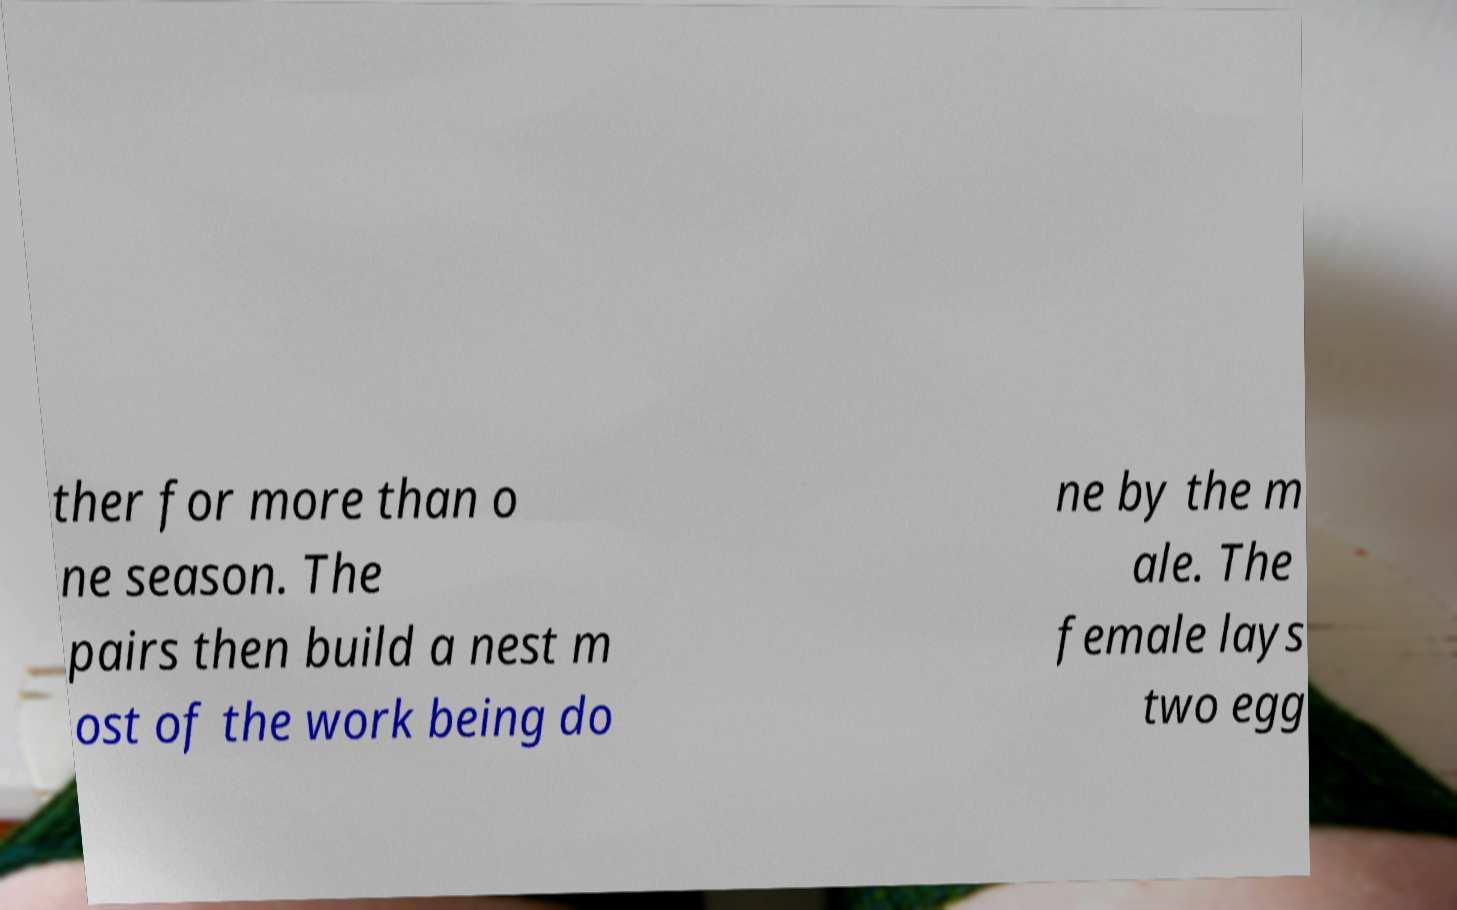Please read and relay the text visible in this image. What does it say? ther for more than o ne season. The pairs then build a nest m ost of the work being do ne by the m ale. The female lays two egg 